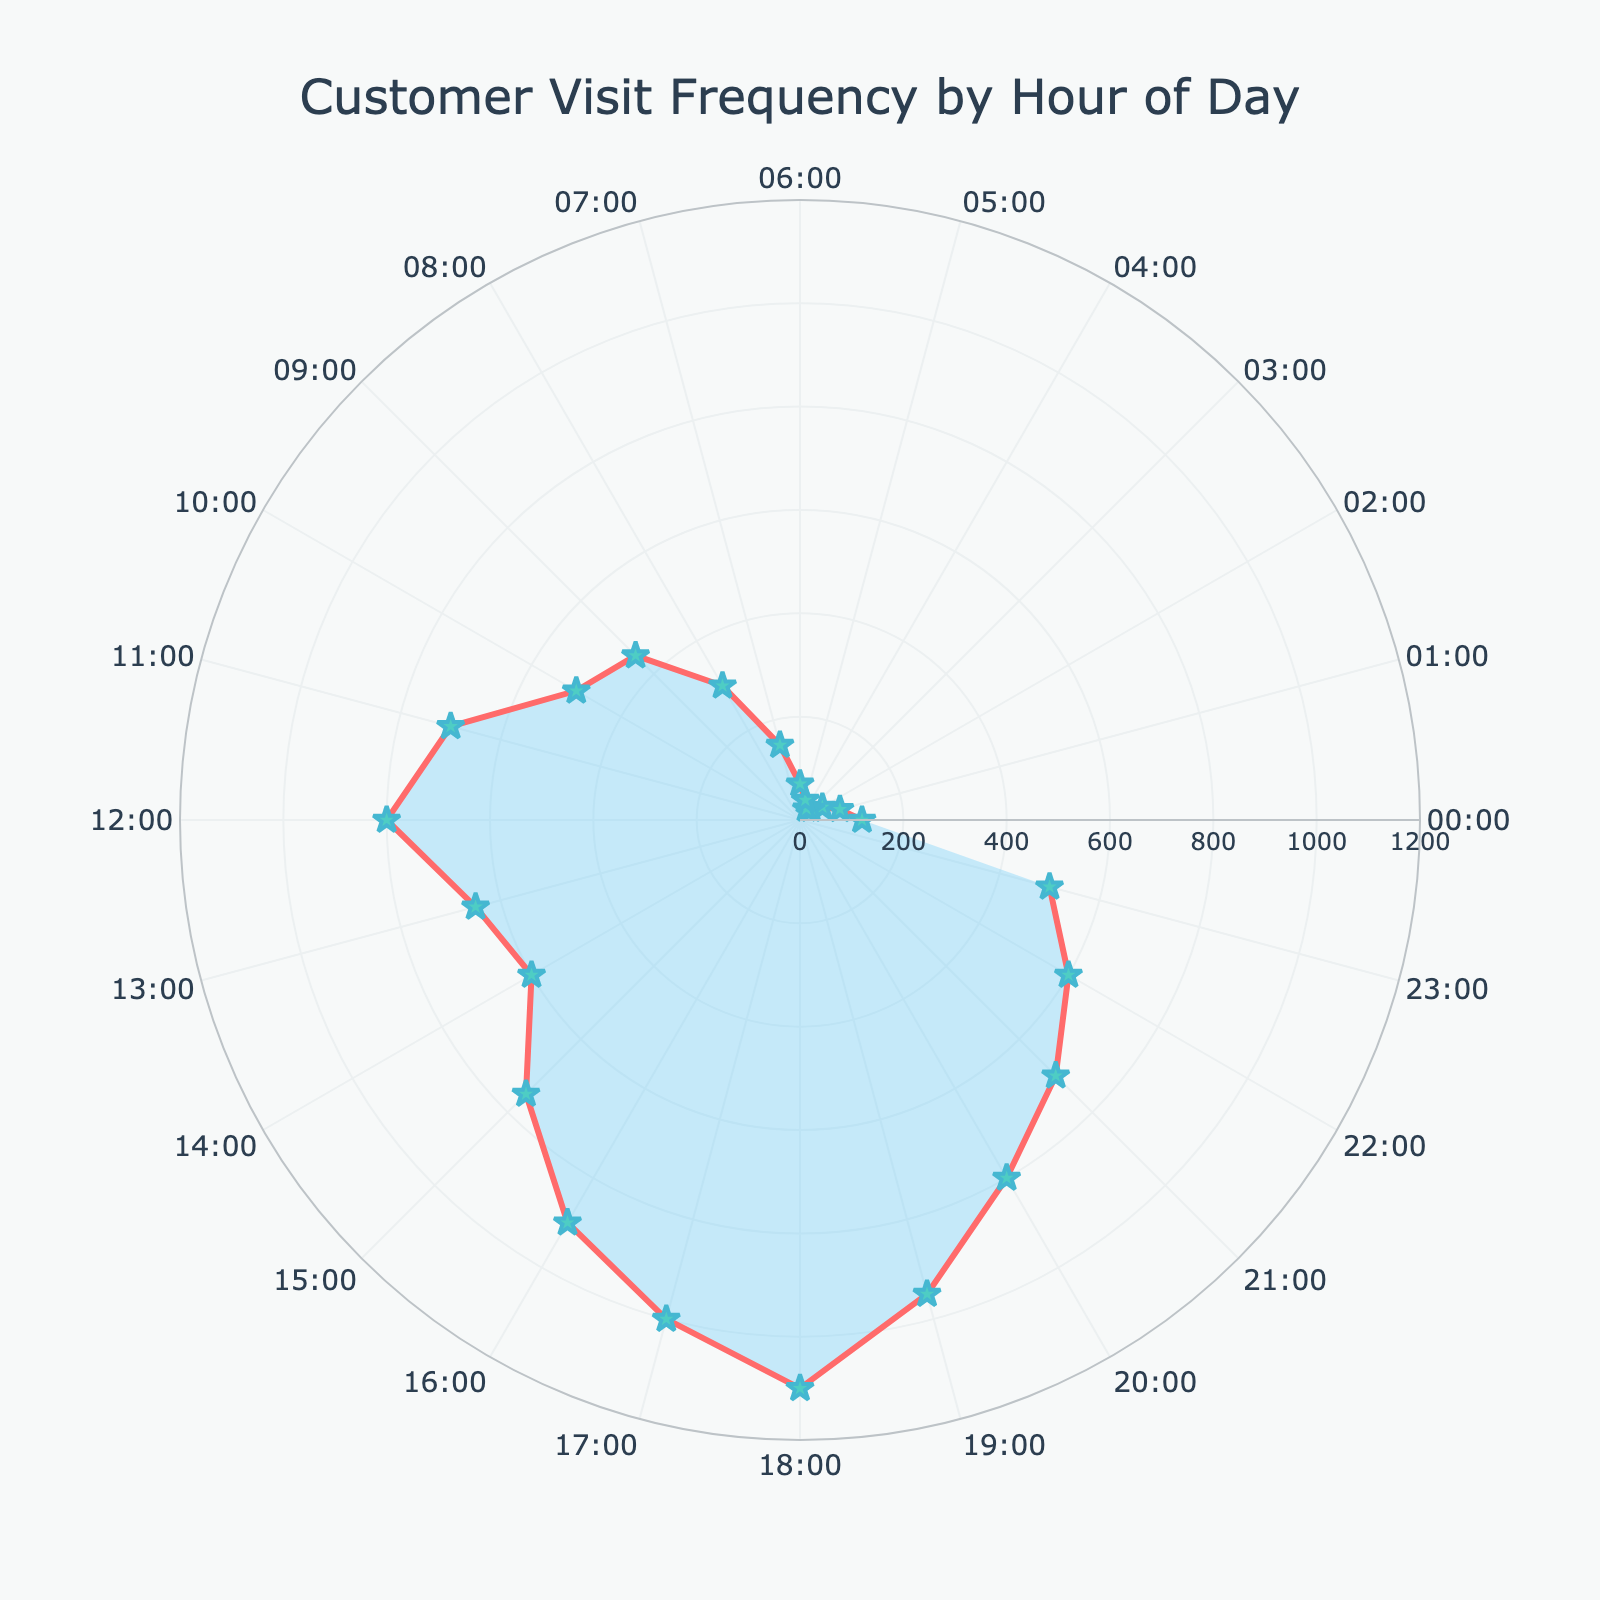What's the title of the figure? The title of a figure is usually displayed at the top. Here, it reads "Customer Visit Frequency by Hour of Day."
Answer: Customer Visit Frequency by Hour of Day What is the range of the radial axis in the figure? The radial axis indicates the range of customer visit frequencies, which can be seen from the innermost circle to the outermost circle, going from 0 to 1200.
Answer: 0 to 1200 During which hour of the day is customer visit frequency the highest? By looking at the data points positioned farthest from the center of the polar chart, we see that the highest frequency occurs at 18:00.
Answer: 18:00 How does the customer visit frequency at 9:00 compare to that at 21:00? The data points at 9:00 and 21:00 show the customer visit frequencies are 450 and 700 respectively. Therefore, the visit frequency at 21:00 is higher.
Answer: 21:00 is higher What's the average customer visit frequency between 10:00 and 14:00 (inclusive)? The visit frequencies from 10:00 to 14:00 are 500, 700, 800, 650, and 600. Summing these values gives 3250, and the average is 3250/5 = 650.
Answer: 650 Which hours fall within the top 3 most frequent customer visit times? The highest frequencies occur at 18:00 (1100 visits), 17:00 (1000 visits), and 19:00 (950 visits).
Answer: 18:00, 17:00, and 19:00 How many data points are plotted in the figure? Each hour of the 24-hour day corresponds to one data point, thus there are 24 data points.
Answer: 24 What's the difference in customer visit frequency between 00:00 and 12:00? The visit frequencies at 00:00 and 12:00 are 120 and 800 respectively. The difference is 800 - 120 = 680.
Answer: 680 How does the visit frequency trend change from morning to evening? Analyzing the chart from the start at 00:00 and moving clockwise, there's a gradual increase with peak values in the late afternoon and a slight decline into the evening hours.
Answer: Increases then decreases What specific feature is used to mark the data points on the chart? The data points are marked using star-shaped markers with a cyan color, and lines connect these points, filled with a light blue shade.
Answer: Star-shaped markers with cyan color 